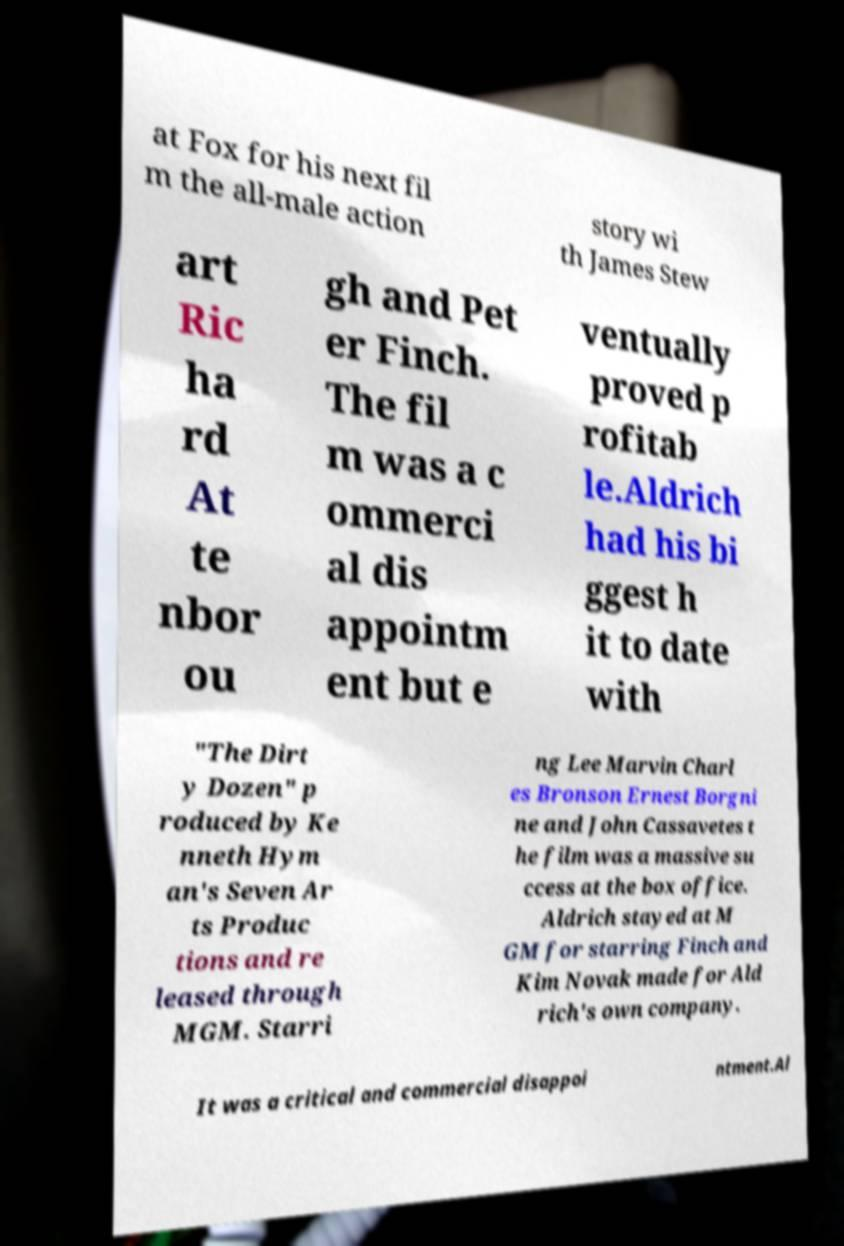Could you assist in decoding the text presented in this image and type it out clearly? at Fox for his next fil m the all-male action story wi th James Stew art Ric ha rd At te nbor ou gh and Pet er Finch. The fil m was a c ommerci al dis appointm ent but e ventually proved p rofitab le.Aldrich had his bi ggest h it to date with "The Dirt y Dozen" p roduced by Ke nneth Hym an's Seven Ar ts Produc tions and re leased through MGM. Starri ng Lee Marvin Charl es Bronson Ernest Borgni ne and John Cassavetes t he film was a massive su ccess at the box office. Aldrich stayed at M GM for starring Finch and Kim Novak made for Ald rich's own company. It was a critical and commercial disappoi ntment.Al 